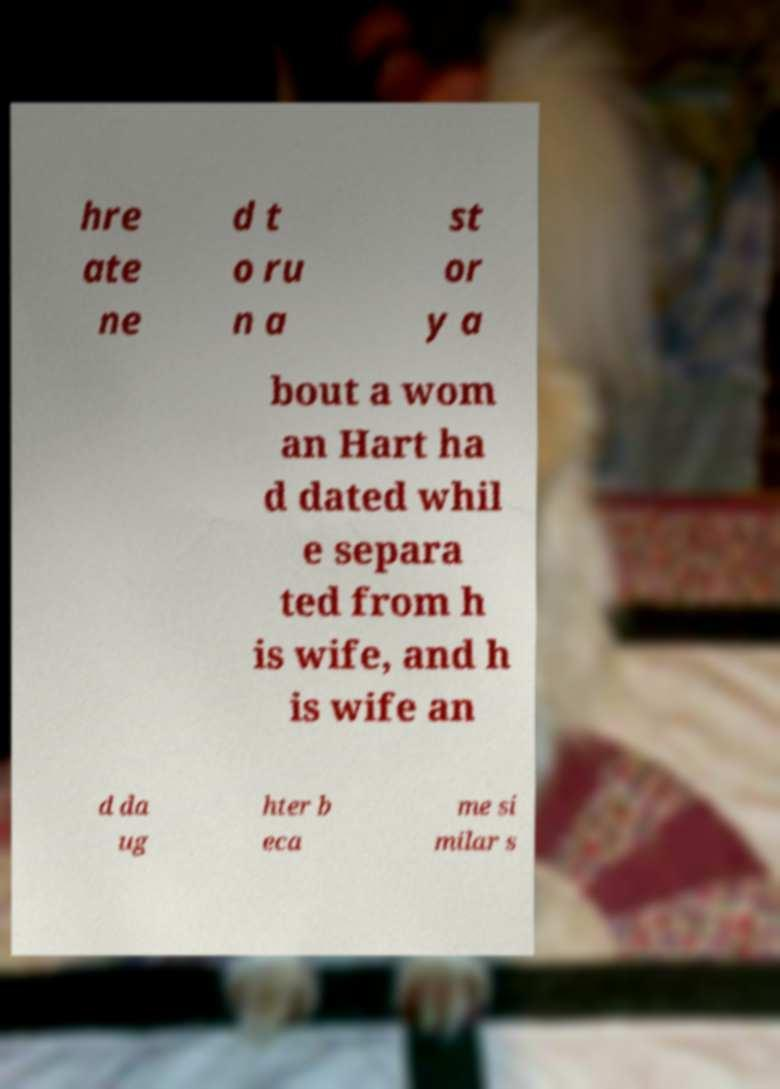Could you assist in decoding the text presented in this image and type it out clearly? hre ate ne d t o ru n a st or y a bout a wom an Hart ha d dated whil e separa ted from h is wife, and h is wife an d da ug hter b eca me si milar s 